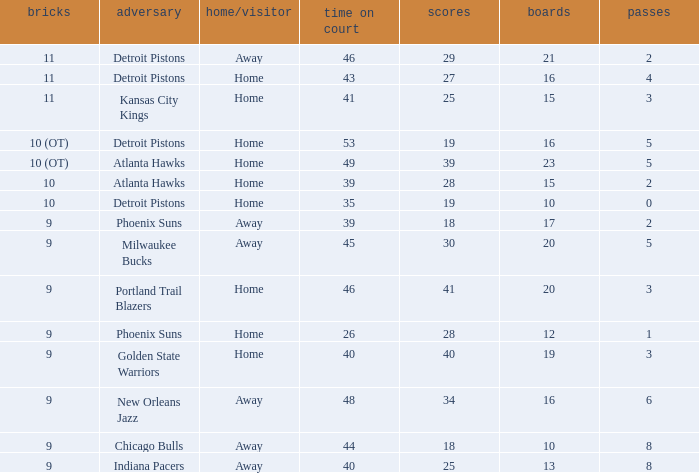How many points were there when there were less than 16 rebounds and 5 assists? 0.0. 